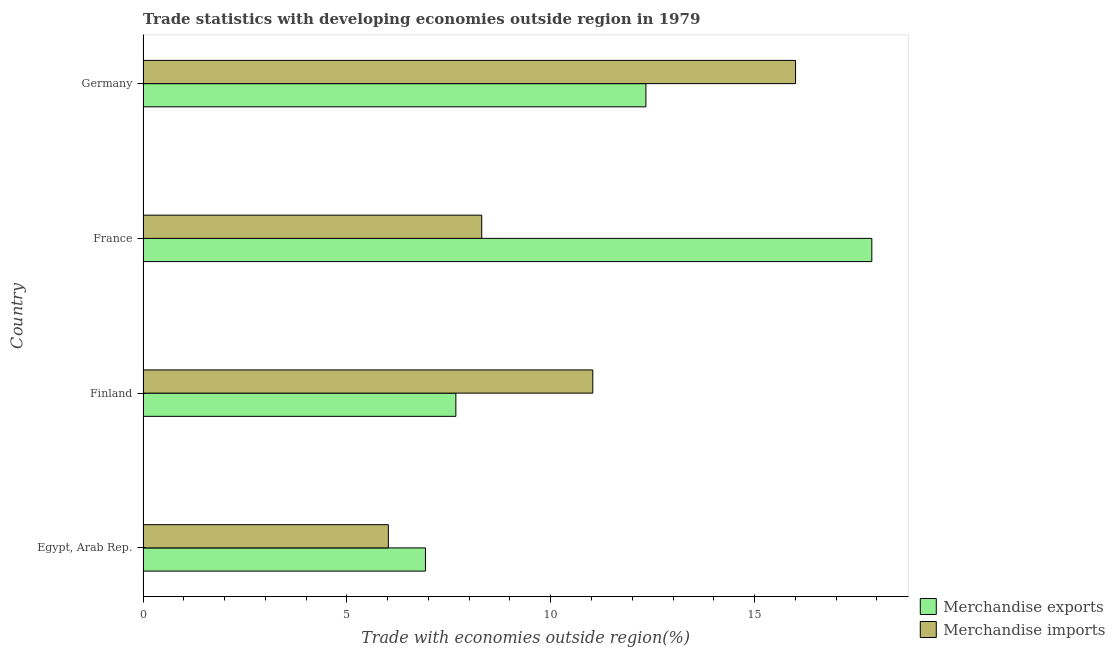How many groups of bars are there?
Give a very brief answer. 4. Are the number of bars per tick equal to the number of legend labels?
Ensure brevity in your answer.  Yes. How many bars are there on the 1st tick from the top?
Make the answer very short. 2. How many bars are there on the 4th tick from the bottom?
Ensure brevity in your answer.  2. What is the label of the 2nd group of bars from the top?
Offer a terse response. France. In how many cases, is the number of bars for a given country not equal to the number of legend labels?
Your answer should be very brief. 0. What is the merchandise exports in France?
Offer a very short reply. 17.88. Across all countries, what is the maximum merchandise exports?
Give a very brief answer. 17.88. Across all countries, what is the minimum merchandise exports?
Ensure brevity in your answer.  6.93. In which country was the merchandise exports maximum?
Keep it short and to the point. France. In which country was the merchandise exports minimum?
Offer a terse response. Egypt, Arab Rep. What is the total merchandise imports in the graph?
Your answer should be compact. 41.36. What is the difference between the merchandise exports in Finland and that in France?
Offer a very short reply. -10.2. What is the difference between the merchandise imports in Finland and the merchandise exports in Egypt, Arab Rep.?
Your answer should be compact. 4.1. What is the average merchandise exports per country?
Offer a very short reply. 11.2. What is the difference between the merchandise imports and merchandise exports in Egypt, Arab Rep.?
Provide a succinct answer. -0.91. In how many countries, is the merchandise imports greater than 12 %?
Your response must be concise. 1. What is the ratio of the merchandise imports in Finland to that in Germany?
Keep it short and to the point. 0.69. Is the difference between the merchandise exports in Egypt, Arab Rep. and France greater than the difference between the merchandise imports in Egypt, Arab Rep. and France?
Provide a short and direct response. No. What is the difference between the highest and the second highest merchandise exports?
Your answer should be compact. 5.54. What is the difference between the highest and the lowest merchandise imports?
Make the answer very short. 9.99. In how many countries, is the merchandise imports greater than the average merchandise imports taken over all countries?
Provide a succinct answer. 2. What does the 1st bar from the top in Finland represents?
Make the answer very short. Merchandise imports. What does the 1st bar from the bottom in France represents?
Provide a short and direct response. Merchandise exports. How many bars are there?
Give a very brief answer. 8. Are all the bars in the graph horizontal?
Give a very brief answer. Yes. Are the values on the major ticks of X-axis written in scientific E-notation?
Offer a terse response. No. Does the graph contain grids?
Make the answer very short. No. Where does the legend appear in the graph?
Keep it short and to the point. Bottom right. How are the legend labels stacked?
Your answer should be compact. Vertical. What is the title of the graph?
Your answer should be very brief. Trade statistics with developing economies outside region in 1979. What is the label or title of the X-axis?
Provide a short and direct response. Trade with economies outside region(%). What is the label or title of the Y-axis?
Keep it short and to the point. Country. What is the Trade with economies outside region(%) of Merchandise exports in Egypt, Arab Rep.?
Make the answer very short. 6.93. What is the Trade with economies outside region(%) in Merchandise imports in Egypt, Arab Rep.?
Offer a terse response. 6.02. What is the Trade with economies outside region(%) in Merchandise exports in Finland?
Your response must be concise. 7.67. What is the Trade with economies outside region(%) of Merchandise imports in Finland?
Keep it short and to the point. 11.03. What is the Trade with economies outside region(%) in Merchandise exports in France?
Offer a terse response. 17.88. What is the Trade with economies outside region(%) of Merchandise imports in France?
Ensure brevity in your answer.  8.31. What is the Trade with economies outside region(%) of Merchandise exports in Germany?
Make the answer very short. 12.33. What is the Trade with economies outside region(%) in Merchandise imports in Germany?
Your answer should be compact. 16.01. Across all countries, what is the maximum Trade with economies outside region(%) in Merchandise exports?
Ensure brevity in your answer.  17.88. Across all countries, what is the maximum Trade with economies outside region(%) in Merchandise imports?
Your response must be concise. 16.01. Across all countries, what is the minimum Trade with economies outside region(%) of Merchandise exports?
Give a very brief answer. 6.93. Across all countries, what is the minimum Trade with economies outside region(%) of Merchandise imports?
Your answer should be compact. 6.02. What is the total Trade with economies outside region(%) in Merchandise exports in the graph?
Give a very brief answer. 44.81. What is the total Trade with economies outside region(%) of Merchandise imports in the graph?
Provide a short and direct response. 41.36. What is the difference between the Trade with economies outside region(%) in Merchandise exports in Egypt, Arab Rep. and that in Finland?
Provide a succinct answer. -0.75. What is the difference between the Trade with economies outside region(%) in Merchandise imports in Egypt, Arab Rep. and that in Finland?
Provide a short and direct response. -5.02. What is the difference between the Trade with economies outside region(%) of Merchandise exports in Egypt, Arab Rep. and that in France?
Offer a very short reply. -10.95. What is the difference between the Trade with economies outside region(%) of Merchandise imports in Egypt, Arab Rep. and that in France?
Keep it short and to the point. -2.29. What is the difference between the Trade with economies outside region(%) of Merchandise exports in Egypt, Arab Rep. and that in Germany?
Offer a very short reply. -5.41. What is the difference between the Trade with economies outside region(%) in Merchandise imports in Egypt, Arab Rep. and that in Germany?
Offer a very short reply. -9.99. What is the difference between the Trade with economies outside region(%) of Merchandise exports in Finland and that in France?
Your response must be concise. -10.2. What is the difference between the Trade with economies outside region(%) of Merchandise imports in Finland and that in France?
Offer a very short reply. 2.72. What is the difference between the Trade with economies outside region(%) in Merchandise exports in Finland and that in Germany?
Make the answer very short. -4.66. What is the difference between the Trade with economies outside region(%) of Merchandise imports in Finland and that in Germany?
Keep it short and to the point. -4.97. What is the difference between the Trade with economies outside region(%) in Merchandise exports in France and that in Germany?
Provide a short and direct response. 5.54. What is the difference between the Trade with economies outside region(%) of Merchandise imports in France and that in Germany?
Provide a short and direct response. -7.7. What is the difference between the Trade with economies outside region(%) in Merchandise exports in Egypt, Arab Rep. and the Trade with economies outside region(%) in Merchandise imports in Finland?
Ensure brevity in your answer.  -4.1. What is the difference between the Trade with economies outside region(%) in Merchandise exports in Egypt, Arab Rep. and the Trade with economies outside region(%) in Merchandise imports in France?
Give a very brief answer. -1.38. What is the difference between the Trade with economies outside region(%) in Merchandise exports in Egypt, Arab Rep. and the Trade with economies outside region(%) in Merchandise imports in Germany?
Your answer should be very brief. -9.08. What is the difference between the Trade with economies outside region(%) of Merchandise exports in Finland and the Trade with economies outside region(%) of Merchandise imports in France?
Your answer should be very brief. -0.63. What is the difference between the Trade with economies outside region(%) of Merchandise exports in Finland and the Trade with economies outside region(%) of Merchandise imports in Germany?
Provide a short and direct response. -8.33. What is the difference between the Trade with economies outside region(%) in Merchandise exports in France and the Trade with economies outside region(%) in Merchandise imports in Germany?
Ensure brevity in your answer.  1.87. What is the average Trade with economies outside region(%) of Merchandise exports per country?
Ensure brevity in your answer.  11.2. What is the average Trade with economies outside region(%) in Merchandise imports per country?
Your response must be concise. 10.34. What is the difference between the Trade with economies outside region(%) of Merchandise exports and Trade with economies outside region(%) of Merchandise imports in Egypt, Arab Rep.?
Offer a very short reply. 0.91. What is the difference between the Trade with economies outside region(%) of Merchandise exports and Trade with economies outside region(%) of Merchandise imports in Finland?
Make the answer very short. -3.36. What is the difference between the Trade with economies outside region(%) of Merchandise exports and Trade with economies outside region(%) of Merchandise imports in France?
Offer a terse response. 9.57. What is the difference between the Trade with economies outside region(%) in Merchandise exports and Trade with economies outside region(%) in Merchandise imports in Germany?
Your answer should be compact. -3.67. What is the ratio of the Trade with economies outside region(%) in Merchandise exports in Egypt, Arab Rep. to that in Finland?
Offer a terse response. 0.9. What is the ratio of the Trade with economies outside region(%) in Merchandise imports in Egypt, Arab Rep. to that in Finland?
Make the answer very short. 0.55. What is the ratio of the Trade with economies outside region(%) of Merchandise exports in Egypt, Arab Rep. to that in France?
Provide a short and direct response. 0.39. What is the ratio of the Trade with economies outside region(%) of Merchandise imports in Egypt, Arab Rep. to that in France?
Your answer should be compact. 0.72. What is the ratio of the Trade with economies outside region(%) in Merchandise exports in Egypt, Arab Rep. to that in Germany?
Keep it short and to the point. 0.56. What is the ratio of the Trade with economies outside region(%) in Merchandise imports in Egypt, Arab Rep. to that in Germany?
Offer a terse response. 0.38. What is the ratio of the Trade with economies outside region(%) of Merchandise exports in Finland to that in France?
Provide a succinct answer. 0.43. What is the ratio of the Trade with economies outside region(%) in Merchandise imports in Finland to that in France?
Your answer should be very brief. 1.33. What is the ratio of the Trade with economies outside region(%) in Merchandise exports in Finland to that in Germany?
Your answer should be very brief. 0.62. What is the ratio of the Trade with economies outside region(%) in Merchandise imports in Finland to that in Germany?
Keep it short and to the point. 0.69. What is the ratio of the Trade with economies outside region(%) of Merchandise exports in France to that in Germany?
Give a very brief answer. 1.45. What is the ratio of the Trade with economies outside region(%) in Merchandise imports in France to that in Germany?
Your answer should be very brief. 0.52. What is the difference between the highest and the second highest Trade with economies outside region(%) in Merchandise exports?
Make the answer very short. 5.54. What is the difference between the highest and the second highest Trade with economies outside region(%) of Merchandise imports?
Your answer should be compact. 4.97. What is the difference between the highest and the lowest Trade with economies outside region(%) of Merchandise exports?
Keep it short and to the point. 10.95. What is the difference between the highest and the lowest Trade with economies outside region(%) of Merchandise imports?
Ensure brevity in your answer.  9.99. 